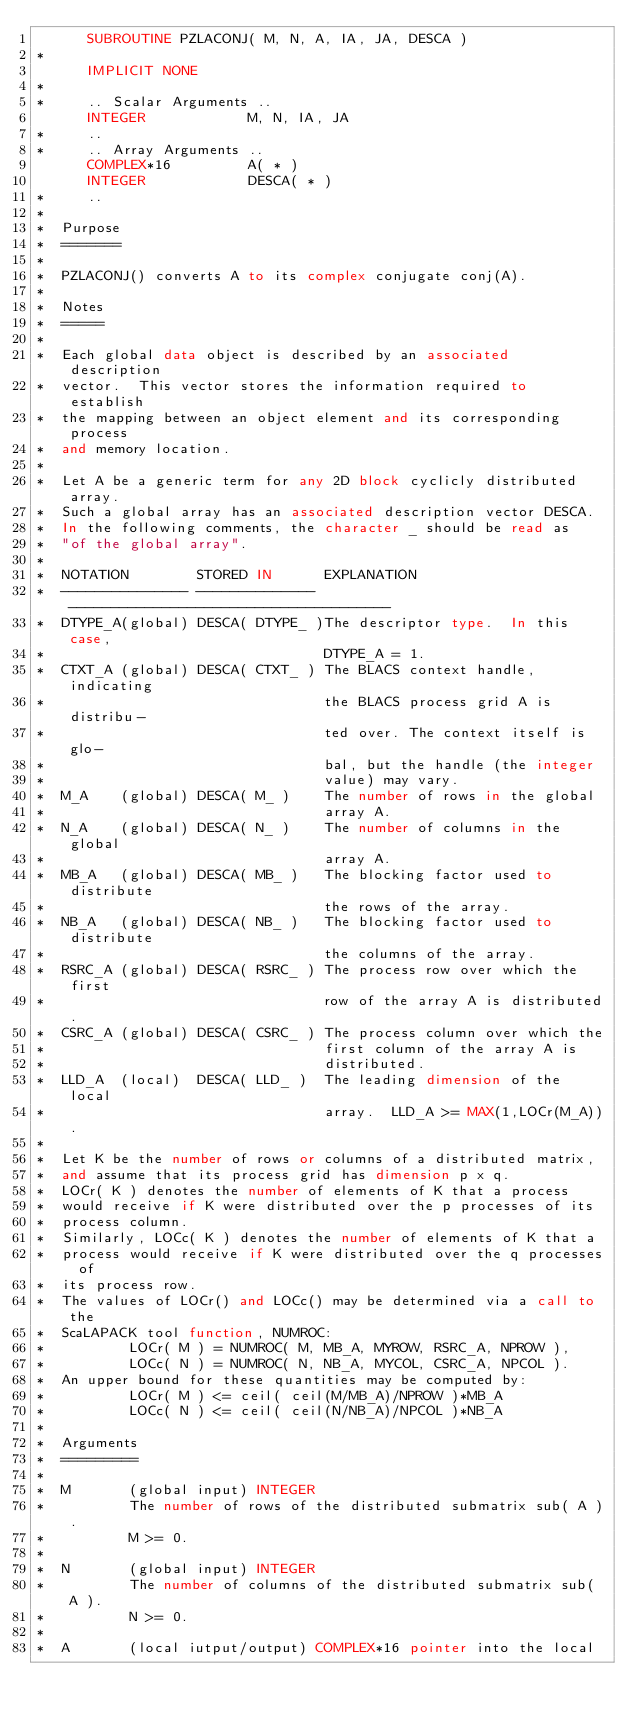<code> <loc_0><loc_0><loc_500><loc_500><_FORTRAN_>      SUBROUTINE PZLACONJ( M, N, A, IA, JA, DESCA )
*
      IMPLICIT NONE
*
*     .. Scalar Arguments ..
      INTEGER            M, N, IA, JA
*     ..
*     .. Array Arguments ..
      COMPLEX*16         A( * )
      INTEGER            DESCA( * )
*     ..
*
*  Purpose
*  =======
*
*  PZLACONJ() converts A to its complex conjugate conj(A).
*
*  Notes
*  =====
*
*  Each global data object is described by an associated description
*  vector.  This vector stores the information required to establish
*  the mapping between an object element and its corresponding process
*  and memory location.
*
*  Let A be a generic term for any 2D block cyclicly distributed array.
*  Such a global array has an associated description vector DESCA.
*  In the following comments, the character _ should be read as
*  "of the global array".
*
*  NOTATION        STORED IN      EXPLANATION
*  --------------- -------------- --------------------------------------
*  DTYPE_A(global) DESCA( DTYPE_ )The descriptor type.  In this case,
*                                 DTYPE_A = 1.
*  CTXT_A (global) DESCA( CTXT_ ) The BLACS context handle, indicating
*                                 the BLACS process grid A is distribu-
*                                 ted over. The context itself is glo-
*                                 bal, but the handle (the integer
*                                 value) may vary.
*  M_A    (global) DESCA( M_ )    The number of rows in the global
*                                 array A.
*  N_A    (global) DESCA( N_ )    The number of columns in the global
*                                 array A.
*  MB_A   (global) DESCA( MB_ )   The blocking factor used to distribute
*                                 the rows of the array.
*  NB_A   (global) DESCA( NB_ )   The blocking factor used to distribute
*                                 the columns of the array.
*  RSRC_A (global) DESCA( RSRC_ ) The process row over which the first
*                                 row of the array A is distributed.
*  CSRC_A (global) DESCA( CSRC_ ) The process column over which the
*                                 first column of the array A is
*                                 distributed.
*  LLD_A  (local)  DESCA( LLD_ )  The leading dimension of the local
*                                 array.  LLD_A >= MAX(1,LOCr(M_A)).
*
*  Let K be the number of rows or columns of a distributed matrix,
*  and assume that its process grid has dimension p x q.
*  LOCr( K ) denotes the number of elements of K that a process
*  would receive if K were distributed over the p processes of its
*  process column.
*  Similarly, LOCc( K ) denotes the number of elements of K that a
*  process would receive if K were distributed over the q processes of
*  its process row.
*  The values of LOCr() and LOCc() may be determined via a call to the
*  ScaLAPACK tool function, NUMROC:
*          LOCr( M ) = NUMROC( M, MB_A, MYROW, RSRC_A, NPROW ),
*          LOCc( N ) = NUMROC( N, NB_A, MYCOL, CSRC_A, NPCOL ).
*  An upper bound for these quantities may be computed by:
*          LOCr( M ) <= ceil( ceil(M/MB_A)/NPROW )*MB_A
*          LOCc( N ) <= ceil( ceil(N/NB_A)/NPCOL )*NB_A
*
*  Arguments
*  =========
*
*  M       (global input) INTEGER
*          The number of rows of the distributed submatrix sub( A ).
*          M >= 0.
*
*  N       (global input) INTEGER
*          The number of columns of the distributed submatrix sub( A ).
*          N >= 0.
*
*  A       (local iutput/output) COMPLEX*16 pointer into the local</code> 